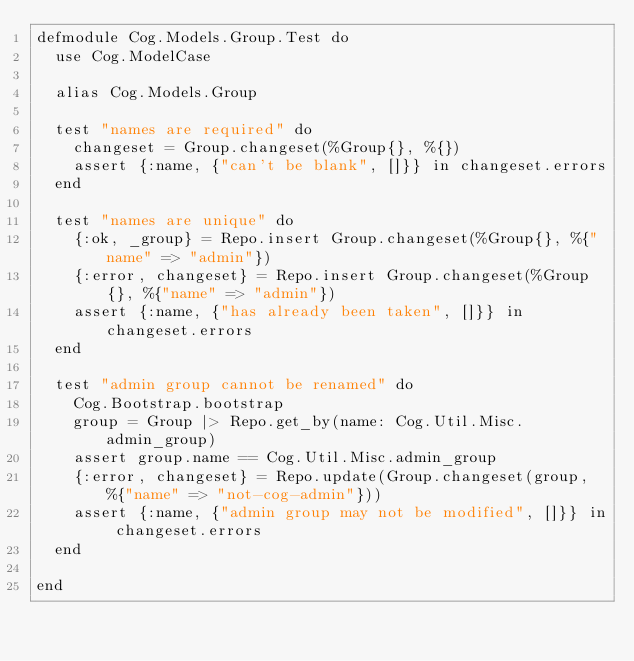Convert code to text. <code><loc_0><loc_0><loc_500><loc_500><_Elixir_>defmodule Cog.Models.Group.Test do
  use Cog.ModelCase

  alias Cog.Models.Group

  test "names are required" do
    changeset = Group.changeset(%Group{}, %{})
    assert {:name, {"can't be blank", []}} in changeset.errors
  end

  test "names are unique" do
    {:ok, _group} = Repo.insert Group.changeset(%Group{}, %{"name" => "admin"})
    {:error, changeset} = Repo.insert Group.changeset(%Group{}, %{"name" => "admin"})
    assert {:name, {"has already been taken", []}} in changeset.errors
  end

  test "admin group cannot be renamed" do
    Cog.Bootstrap.bootstrap
    group = Group |> Repo.get_by(name: Cog.Util.Misc.admin_group)
    assert group.name == Cog.Util.Misc.admin_group
    {:error, changeset} = Repo.update(Group.changeset(group, %{"name" => "not-cog-admin"}))
    assert {:name, {"admin group may not be modified", []}} in changeset.errors
  end

end
</code> 